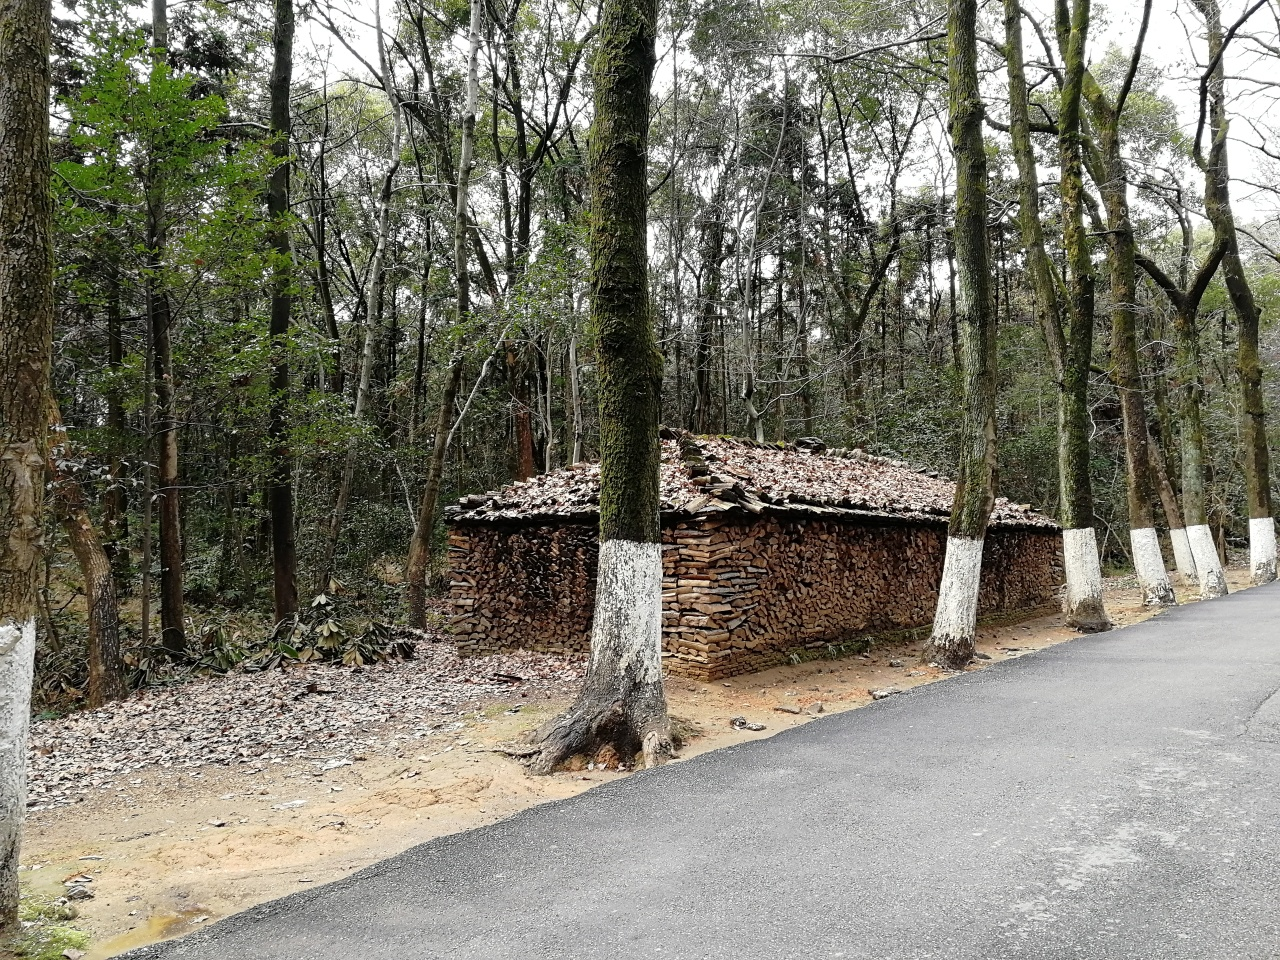How would you describe the clarity of the outlines of the trees and textures on the trunks? The outlines of the trees in the image are distinctly clear against the sky and the surrounding vegetation. Each trunk exhibits a variety of textures, with the rough bark clearly visible and the intricate patterns on the surface suggesting a range of tree species. The well-defined tree rings and the way the light hits them augment their natural beauty, contributing to a scene rich in detail. 